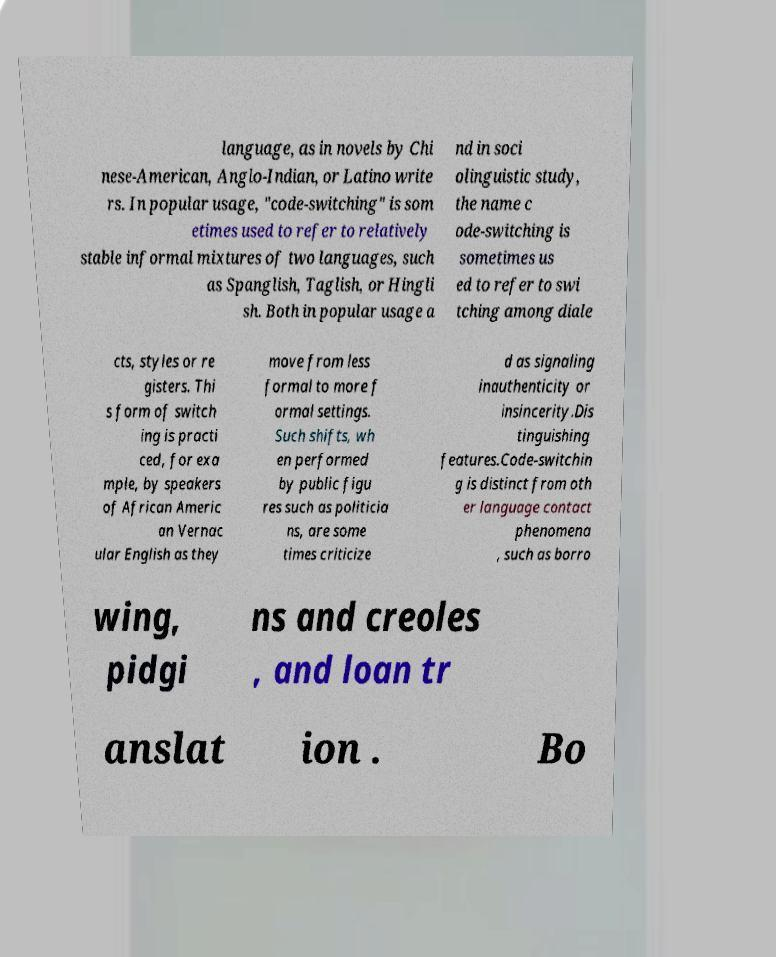What messages or text are displayed in this image? I need them in a readable, typed format. language, as in novels by Chi nese-American, Anglo-Indian, or Latino write rs. In popular usage, "code-switching" is som etimes used to refer to relatively stable informal mixtures of two languages, such as Spanglish, Taglish, or Hingli sh. Both in popular usage a nd in soci olinguistic study, the name c ode-switching is sometimes us ed to refer to swi tching among diale cts, styles or re gisters. Thi s form of switch ing is practi ced, for exa mple, by speakers of African Americ an Vernac ular English as they move from less formal to more f ormal settings. Such shifts, wh en performed by public figu res such as politicia ns, are some times criticize d as signaling inauthenticity or insincerity.Dis tinguishing features.Code-switchin g is distinct from oth er language contact phenomena , such as borro wing, pidgi ns and creoles , and loan tr anslat ion . Bo 